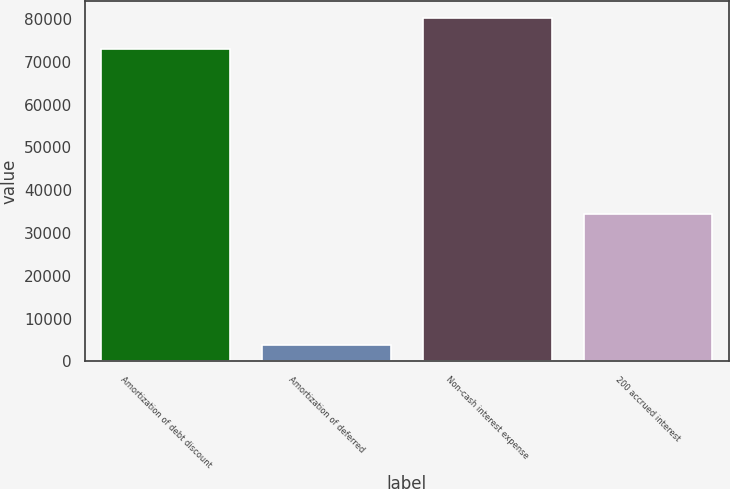Convert chart. <chart><loc_0><loc_0><loc_500><loc_500><bar_chart><fcel>Amortization of debt discount<fcel>Amortization of deferred<fcel>Non-cash interest expense<fcel>200 accrued interest<nl><fcel>72908<fcel>3906<fcel>80198.8<fcel>34427<nl></chart> 